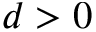Convert formula to latex. <formula><loc_0><loc_0><loc_500><loc_500>d > 0</formula> 